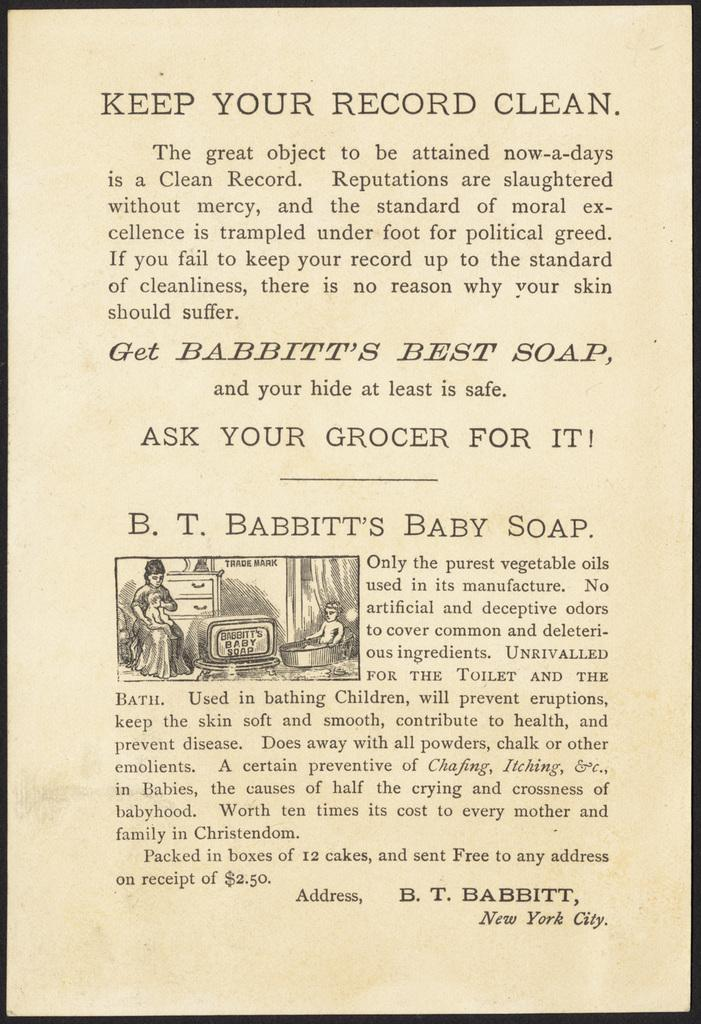What is the image printed on? The image is on a paper. What is the woman in the image doing? The woman is sitting on a chair and holding a baby. What can be seen on the paper besides the image? There are words on the paper. Where is the faucet located in the image? There is no faucet present in the image. What type of pies is the woman holding in the image? The woman is not holding any pies in the image; she is holding a baby. 